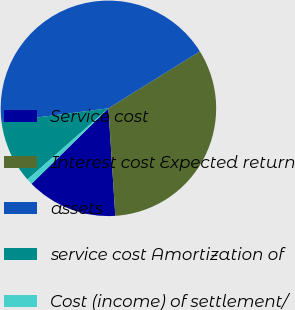Convert chart to OTSL. <chart><loc_0><loc_0><loc_500><loc_500><pie_chart><fcel>Service cost<fcel>Interest cost Expected return<fcel>assets<fcel>service cost Amortization of<fcel>Cost (income) of settlement/<nl><fcel>13.67%<fcel>32.85%<fcel>43.17%<fcel>9.44%<fcel>0.88%<nl></chart> 